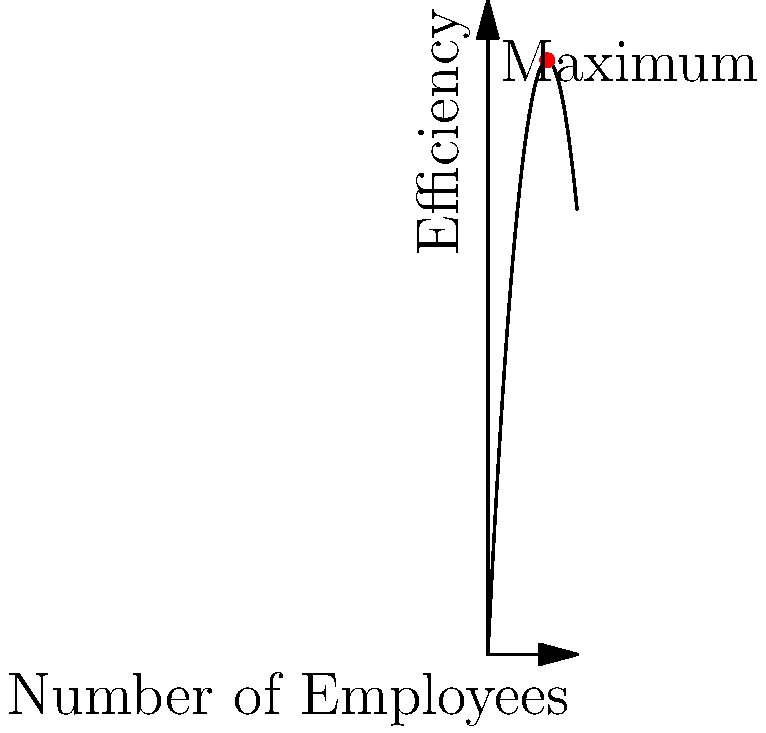Your startup's efficiency (E) as a function of the number of employees (x) is given by the parabolic function $E(x) = -0.5x^2 + 20x$, where efficiency is measured in arbitrary units. Determine the ideal number of employees to maximize efficiency and calculate the maximum efficiency achieved. To solve this optimization problem, we need to follow these steps:

1) The function given is $E(x) = -0.5x^2 + 20x$

2) To find the maximum, we need to find where the derivative equals zero:
   $\frac{dE}{dx} = -x + 20$

3) Set the derivative to zero and solve:
   $-x + 20 = 0$
   $x = 20$

4) The second derivative is negative ($\frac{d^2E}{dx^2} = -1$), confirming this is a maximum.

5) Therefore, the ideal number of employees is 20.

6) To find the maximum efficiency, plug x = 20 into the original function:
   $E(20) = -0.5(20)^2 + 20(20)$
   $= -200 + 400$
   $= 200$

Thus, the maximum efficiency is 200 units.
Answer: 20 employees; 200 efficiency units 